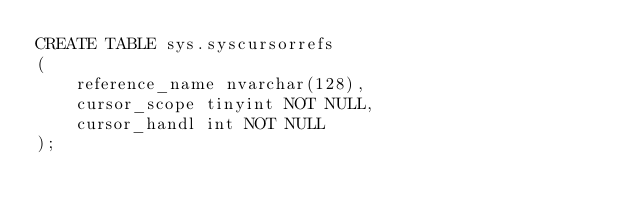Convert code to text. <code><loc_0><loc_0><loc_500><loc_500><_SQL_>CREATE TABLE sys.syscursorrefs
(
    reference_name nvarchar(128),
    cursor_scope tinyint NOT NULL,
    cursor_handl int NOT NULL
);</code> 